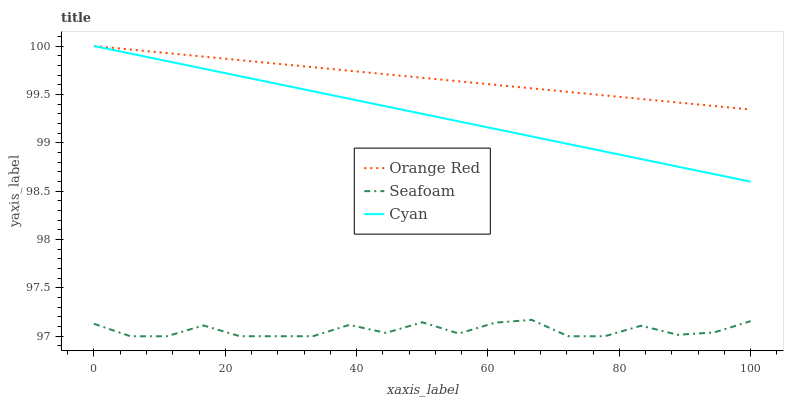Does Orange Red have the minimum area under the curve?
Answer yes or no. No. Does Seafoam have the maximum area under the curve?
Answer yes or no. No. Is Orange Red the smoothest?
Answer yes or no. No. Is Orange Red the roughest?
Answer yes or no. No. Does Orange Red have the lowest value?
Answer yes or no. No. Does Seafoam have the highest value?
Answer yes or no. No. Is Seafoam less than Cyan?
Answer yes or no. Yes. Is Cyan greater than Seafoam?
Answer yes or no. Yes. Does Seafoam intersect Cyan?
Answer yes or no. No. 